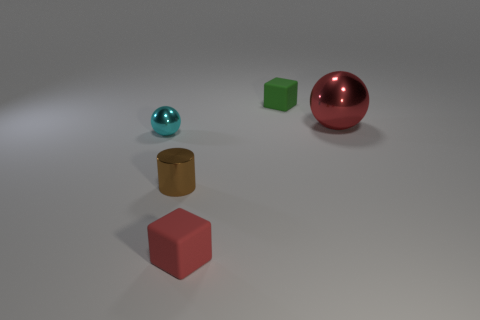Add 4 large red balls. How many objects exist? 9 Subtract all spheres. How many objects are left? 3 Subtract 1 red blocks. How many objects are left? 4 Subtract all big green shiny cylinders. Subtract all red matte cubes. How many objects are left? 4 Add 2 cyan metal spheres. How many cyan metal spheres are left? 3 Add 4 matte blocks. How many matte blocks exist? 6 